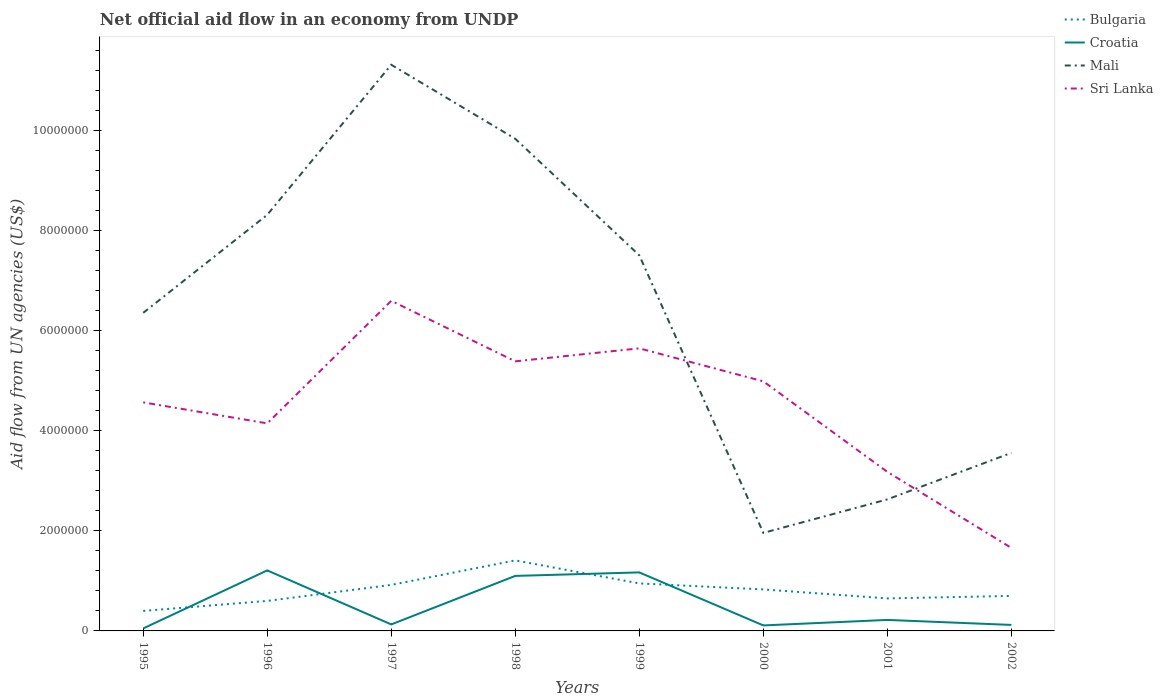How many different coloured lines are there?
Make the answer very short. 4. Across all years, what is the maximum net official aid flow in Sri Lanka?
Keep it short and to the point. 1.66e+06. What is the total net official aid flow in Croatia in the graph?
Your answer should be very brief. -7.00e+04. What is the difference between the highest and the second highest net official aid flow in Croatia?
Provide a succinct answer. 1.16e+06. What is the difference between two consecutive major ticks on the Y-axis?
Your answer should be very brief. 2.00e+06. Are the values on the major ticks of Y-axis written in scientific E-notation?
Your answer should be very brief. No. Does the graph contain grids?
Give a very brief answer. No. Where does the legend appear in the graph?
Give a very brief answer. Top right. How are the legend labels stacked?
Offer a very short reply. Vertical. What is the title of the graph?
Offer a very short reply. Net official aid flow in an economy from UNDP. What is the label or title of the X-axis?
Offer a very short reply. Years. What is the label or title of the Y-axis?
Make the answer very short. Aid flow from UN agencies (US$). What is the Aid flow from UN agencies (US$) in Bulgaria in 1995?
Offer a terse response. 4.00e+05. What is the Aid flow from UN agencies (US$) of Mali in 1995?
Keep it short and to the point. 6.36e+06. What is the Aid flow from UN agencies (US$) of Sri Lanka in 1995?
Provide a succinct answer. 4.57e+06. What is the Aid flow from UN agencies (US$) in Bulgaria in 1996?
Provide a succinct answer. 6.00e+05. What is the Aid flow from UN agencies (US$) in Croatia in 1996?
Keep it short and to the point. 1.21e+06. What is the Aid flow from UN agencies (US$) of Mali in 1996?
Your answer should be very brief. 8.32e+06. What is the Aid flow from UN agencies (US$) in Sri Lanka in 1996?
Give a very brief answer. 4.15e+06. What is the Aid flow from UN agencies (US$) of Bulgaria in 1997?
Give a very brief answer. 9.20e+05. What is the Aid flow from UN agencies (US$) of Mali in 1997?
Provide a short and direct response. 1.13e+07. What is the Aid flow from UN agencies (US$) in Sri Lanka in 1997?
Ensure brevity in your answer.  6.60e+06. What is the Aid flow from UN agencies (US$) in Bulgaria in 1998?
Make the answer very short. 1.41e+06. What is the Aid flow from UN agencies (US$) of Croatia in 1998?
Make the answer very short. 1.10e+06. What is the Aid flow from UN agencies (US$) in Mali in 1998?
Provide a succinct answer. 9.84e+06. What is the Aid flow from UN agencies (US$) in Sri Lanka in 1998?
Make the answer very short. 5.39e+06. What is the Aid flow from UN agencies (US$) in Bulgaria in 1999?
Make the answer very short. 9.50e+05. What is the Aid flow from UN agencies (US$) in Croatia in 1999?
Your response must be concise. 1.17e+06. What is the Aid flow from UN agencies (US$) of Mali in 1999?
Offer a terse response. 7.51e+06. What is the Aid flow from UN agencies (US$) of Sri Lanka in 1999?
Your answer should be very brief. 5.65e+06. What is the Aid flow from UN agencies (US$) of Bulgaria in 2000?
Make the answer very short. 8.30e+05. What is the Aid flow from UN agencies (US$) of Croatia in 2000?
Make the answer very short. 1.10e+05. What is the Aid flow from UN agencies (US$) in Mali in 2000?
Your answer should be very brief. 1.96e+06. What is the Aid flow from UN agencies (US$) in Sri Lanka in 2000?
Give a very brief answer. 4.99e+06. What is the Aid flow from UN agencies (US$) of Bulgaria in 2001?
Ensure brevity in your answer.  6.50e+05. What is the Aid flow from UN agencies (US$) of Mali in 2001?
Your response must be concise. 2.63e+06. What is the Aid flow from UN agencies (US$) of Sri Lanka in 2001?
Your answer should be compact. 3.18e+06. What is the Aid flow from UN agencies (US$) of Bulgaria in 2002?
Your answer should be very brief. 7.00e+05. What is the Aid flow from UN agencies (US$) in Croatia in 2002?
Give a very brief answer. 1.20e+05. What is the Aid flow from UN agencies (US$) in Mali in 2002?
Provide a short and direct response. 3.56e+06. What is the Aid flow from UN agencies (US$) of Sri Lanka in 2002?
Offer a very short reply. 1.66e+06. Across all years, what is the maximum Aid flow from UN agencies (US$) of Bulgaria?
Your response must be concise. 1.41e+06. Across all years, what is the maximum Aid flow from UN agencies (US$) of Croatia?
Your answer should be very brief. 1.21e+06. Across all years, what is the maximum Aid flow from UN agencies (US$) in Mali?
Your response must be concise. 1.13e+07. Across all years, what is the maximum Aid flow from UN agencies (US$) of Sri Lanka?
Offer a terse response. 6.60e+06. Across all years, what is the minimum Aid flow from UN agencies (US$) in Mali?
Give a very brief answer. 1.96e+06. Across all years, what is the minimum Aid flow from UN agencies (US$) in Sri Lanka?
Your answer should be very brief. 1.66e+06. What is the total Aid flow from UN agencies (US$) in Bulgaria in the graph?
Provide a succinct answer. 6.46e+06. What is the total Aid flow from UN agencies (US$) in Croatia in the graph?
Offer a very short reply. 4.11e+06. What is the total Aid flow from UN agencies (US$) in Mali in the graph?
Give a very brief answer. 5.15e+07. What is the total Aid flow from UN agencies (US$) in Sri Lanka in the graph?
Your response must be concise. 3.62e+07. What is the difference between the Aid flow from UN agencies (US$) of Croatia in 1995 and that in 1996?
Your answer should be very brief. -1.16e+06. What is the difference between the Aid flow from UN agencies (US$) of Mali in 1995 and that in 1996?
Give a very brief answer. -1.96e+06. What is the difference between the Aid flow from UN agencies (US$) of Bulgaria in 1995 and that in 1997?
Your answer should be compact. -5.20e+05. What is the difference between the Aid flow from UN agencies (US$) in Mali in 1995 and that in 1997?
Your answer should be very brief. -4.96e+06. What is the difference between the Aid flow from UN agencies (US$) of Sri Lanka in 1995 and that in 1997?
Your answer should be very brief. -2.03e+06. What is the difference between the Aid flow from UN agencies (US$) in Bulgaria in 1995 and that in 1998?
Your answer should be very brief. -1.01e+06. What is the difference between the Aid flow from UN agencies (US$) in Croatia in 1995 and that in 1998?
Offer a terse response. -1.05e+06. What is the difference between the Aid flow from UN agencies (US$) in Mali in 1995 and that in 1998?
Provide a short and direct response. -3.48e+06. What is the difference between the Aid flow from UN agencies (US$) in Sri Lanka in 1995 and that in 1998?
Provide a succinct answer. -8.20e+05. What is the difference between the Aid flow from UN agencies (US$) in Bulgaria in 1995 and that in 1999?
Offer a terse response. -5.50e+05. What is the difference between the Aid flow from UN agencies (US$) in Croatia in 1995 and that in 1999?
Keep it short and to the point. -1.12e+06. What is the difference between the Aid flow from UN agencies (US$) of Mali in 1995 and that in 1999?
Give a very brief answer. -1.15e+06. What is the difference between the Aid flow from UN agencies (US$) in Sri Lanka in 1995 and that in 1999?
Offer a terse response. -1.08e+06. What is the difference between the Aid flow from UN agencies (US$) in Bulgaria in 1995 and that in 2000?
Make the answer very short. -4.30e+05. What is the difference between the Aid flow from UN agencies (US$) of Mali in 1995 and that in 2000?
Provide a short and direct response. 4.40e+06. What is the difference between the Aid flow from UN agencies (US$) of Sri Lanka in 1995 and that in 2000?
Keep it short and to the point. -4.20e+05. What is the difference between the Aid flow from UN agencies (US$) of Bulgaria in 1995 and that in 2001?
Offer a very short reply. -2.50e+05. What is the difference between the Aid flow from UN agencies (US$) of Croatia in 1995 and that in 2001?
Give a very brief answer. -1.70e+05. What is the difference between the Aid flow from UN agencies (US$) in Mali in 1995 and that in 2001?
Your answer should be compact. 3.73e+06. What is the difference between the Aid flow from UN agencies (US$) in Sri Lanka in 1995 and that in 2001?
Make the answer very short. 1.39e+06. What is the difference between the Aid flow from UN agencies (US$) of Bulgaria in 1995 and that in 2002?
Keep it short and to the point. -3.00e+05. What is the difference between the Aid flow from UN agencies (US$) in Mali in 1995 and that in 2002?
Give a very brief answer. 2.80e+06. What is the difference between the Aid flow from UN agencies (US$) of Sri Lanka in 1995 and that in 2002?
Your answer should be compact. 2.91e+06. What is the difference between the Aid flow from UN agencies (US$) in Bulgaria in 1996 and that in 1997?
Your answer should be compact. -3.20e+05. What is the difference between the Aid flow from UN agencies (US$) in Croatia in 1996 and that in 1997?
Your response must be concise. 1.08e+06. What is the difference between the Aid flow from UN agencies (US$) in Mali in 1996 and that in 1997?
Offer a very short reply. -3.00e+06. What is the difference between the Aid flow from UN agencies (US$) in Sri Lanka in 1996 and that in 1997?
Give a very brief answer. -2.45e+06. What is the difference between the Aid flow from UN agencies (US$) of Bulgaria in 1996 and that in 1998?
Make the answer very short. -8.10e+05. What is the difference between the Aid flow from UN agencies (US$) in Mali in 1996 and that in 1998?
Offer a terse response. -1.52e+06. What is the difference between the Aid flow from UN agencies (US$) of Sri Lanka in 1996 and that in 1998?
Your answer should be compact. -1.24e+06. What is the difference between the Aid flow from UN agencies (US$) of Bulgaria in 1996 and that in 1999?
Offer a terse response. -3.50e+05. What is the difference between the Aid flow from UN agencies (US$) in Croatia in 1996 and that in 1999?
Make the answer very short. 4.00e+04. What is the difference between the Aid flow from UN agencies (US$) in Mali in 1996 and that in 1999?
Your answer should be compact. 8.10e+05. What is the difference between the Aid flow from UN agencies (US$) of Sri Lanka in 1996 and that in 1999?
Offer a very short reply. -1.50e+06. What is the difference between the Aid flow from UN agencies (US$) in Bulgaria in 1996 and that in 2000?
Give a very brief answer. -2.30e+05. What is the difference between the Aid flow from UN agencies (US$) in Croatia in 1996 and that in 2000?
Provide a succinct answer. 1.10e+06. What is the difference between the Aid flow from UN agencies (US$) of Mali in 1996 and that in 2000?
Offer a very short reply. 6.36e+06. What is the difference between the Aid flow from UN agencies (US$) in Sri Lanka in 1996 and that in 2000?
Ensure brevity in your answer.  -8.40e+05. What is the difference between the Aid flow from UN agencies (US$) of Bulgaria in 1996 and that in 2001?
Your answer should be compact. -5.00e+04. What is the difference between the Aid flow from UN agencies (US$) in Croatia in 1996 and that in 2001?
Provide a succinct answer. 9.90e+05. What is the difference between the Aid flow from UN agencies (US$) of Mali in 1996 and that in 2001?
Make the answer very short. 5.69e+06. What is the difference between the Aid flow from UN agencies (US$) of Sri Lanka in 1996 and that in 2001?
Keep it short and to the point. 9.70e+05. What is the difference between the Aid flow from UN agencies (US$) of Bulgaria in 1996 and that in 2002?
Ensure brevity in your answer.  -1.00e+05. What is the difference between the Aid flow from UN agencies (US$) in Croatia in 1996 and that in 2002?
Your answer should be very brief. 1.09e+06. What is the difference between the Aid flow from UN agencies (US$) in Mali in 1996 and that in 2002?
Give a very brief answer. 4.76e+06. What is the difference between the Aid flow from UN agencies (US$) of Sri Lanka in 1996 and that in 2002?
Your answer should be compact. 2.49e+06. What is the difference between the Aid flow from UN agencies (US$) in Bulgaria in 1997 and that in 1998?
Your response must be concise. -4.90e+05. What is the difference between the Aid flow from UN agencies (US$) of Croatia in 1997 and that in 1998?
Make the answer very short. -9.70e+05. What is the difference between the Aid flow from UN agencies (US$) of Mali in 1997 and that in 1998?
Your answer should be very brief. 1.48e+06. What is the difference between the Aid flow from UN agencies (US$) in Sri Lanka in 1997 and that in 1998?
Your answer should be very brief. 1.21e+06. What is the difference between the Aid flow from UN agencies (US$) of Croatia in 1997 and that in 1999?
Provide a succinct answer. -1.04e+06. What is the difference between the Aid flow from UN agencies (US$) in Mali in 1997 and that in 1999?
Provide a short and direct response. 3.81e+06. What is the difference between the Aid flow from UN agencies (US$) in Sri Lanka in 1997 and that in 1999?
Provide a succinct answer. 9.50e+05. What is the difference between the Aid flow from UN agencies (US$) in Bulgaria in 1997 and that in 2000?
Your answer should be very brief. 9.00e+04. What is the difference between the Aid flow from UN agencies (US$) of Mali in 1997 and that in 2000?
Keep it short and to the point. 9.36e+06. What is the difference between the Aid flow from UN agencies (US$) in Sri Lanka in 1997 and that in 2000?
Provide a succinct answer. 1.61e+06. What is the difference between the Aid flow from UN agencies (US$) of Mali in 1997 and that in 2001?
Ensure brevity in your answer.  8.69e+06. What is the difference between the Aid flow from UN agencies (US$) in Sri Lanka in 1997 and that in 2001?
Your response must be concise. 3.42e+06. What is the difference between the Aid flow from UN agencies (US$) in Croatia in 1997 and that in 2002?
Give a very brief answer. 10000. What is the difference between the Aid flow from UN agencies (US$) of Mali in 1997 and that in 2002?
Provide a short and direct response. 7.76e+06. What is the difference between the Aid flow from UN agencies (US$) in Sri Lanka in 1997 and that in 2002?
Your answer should be compact. 4.94e+06. What is the difference between the Aid flow from UN agencies (US$) of Bulgaria in 1998 and that in 1999?
Keep it short and to the point. 4.60e+05. What is the difference between the Aid flow from UN agencies (US$) in Croatia in 1998 and that in 1999?
Make the answer very short. -7.00e+04. What is the difference between the Aid flow from UN agencies (US$) in Mali in 1998 and that in 1999?
Provide a short and direct response. 2.33e+06. What is the difference between the Aid flow from UN agencies (US$) in Bulgaria in 1998 and that in 2000?
Offer a terse response. 5.80e+05. What is the difference between the Aid flow from UN agencies (US$) of Croatia in 1998 and that in 2000?
Ensure brevity in your answer.  9.90e+05. What is the difference between the Aid flow from UN agencies (US$) of Mali in 1998 and that in 2000?
Your answer should be compact. 7.88e+06. What is the difference between the Aid flow from UN agencies (US$) in Bulgaria in 1998 and that in 2001?
Your answer should be compact. 7.60e+05. What is the difference between the Aid flow from UN agencies (US$) in Croatia in 1998 and that in 2001?
Make the answer very short. 8.80e+05. What is the difference between the Aid flow from UN agencies (US$) of Mali in 1998 and that in 2001?
Offer a terse response. 7.21e+06. What is the difference between the Aid flow from UN agencies (US$) in Sri Lanka in 1998 and that in 2001?
Offer a terse response. 2.21e+06. What is the difference between the Aid flow from UN agencies (US$) of Bulgaria in 1998 and that in 2002?
Provide a short and direct response. 7.10e+05. What is the difference between the Aid flow from UN agencies (US$) in Croatia in 1998 and that in 2002?
Your response must be concise. 9.80e+05. What is the difference between the Aid flow from UN agencies (US$) in Mali in 1998 and that in 2002?
Offer a terse response. 6.28e+06. What is the difference between the Aid flow from UN agencies (US$) of Sri Lanka in 1998 and that in 2002?
Your response must be concise. 3.73e+06. What is the difference between the Aid flow from UN agencies (US$) of Croatia in 1999 and that in 2000?
Offer a very short reply. 1.06e+06. What is the difference between the Aid flow from UN agencies (US$) of Mali in 1999 and that in 2000?
Your answer should be very brief. 5.55e+06. What is the difference between the Aid flow from UN agencies (US$) of Sri Lanka in 1999 and that in 2000?
Your answer should be compact. 6.60e+05. What is the difference between the Aid flow from UN agencies (US$) of Bulgaria in 1999 and that in 2001?
Give a very brief answer. 3.00e+05. What is the difference between the Aid flow from UN agencies (US$) in Croatia in 1999 and that in 2001?
Offer a very short reply. 9.50e+05. What is the difference between the Aid flow from UN agencies (US$) of Mali in 1999 and that in 2001?
Your answer should be very brief. 4.88e+06. What is the difference between the Aid flow from UN agencies (US$) in Sri Lanka in 1999 and that in 2001?
Offer a very short reply. 2.47e+06. What is the difference between the Aid flow from UN agencies (US$) of Croatia in 1999 and that in 2002?
Your answer should be compact. 1.05e+06. What is the difference between the Aid flow from UN agencies (US$) of Mali in 1999 and that in 2002?
Ensure brevity in your answer.  3.95e+06. What is the difference between the Aid flow from UN agencies (US$) of Sri Lanka in 1999 and that in 2002?
Offer a very short reply. 3.99e+06. What is the difference between the Aid flow from UN agencies (US$) in Bulgaria in 2000 and that in 2001?
Offer a terse response. 1.80e+05. What is the difference between the Aid flow from UN agencies (US$) in Croatia in 2000 and that in 2001?
Provide a short and direct response. -1.10e+05. What is the difference between the Aid flow from UN agencies (US$) in Mali in 2000 and that in 2001?
Provide a succinct answer. -6.70e+05. What is the difference between the Aid flow from UN agencies (US$) in Sri Lanka in 2000 and that in 2001?
Ensure brevity in your answer.  1.81e+06. What is the difference between the Aid flow from UN agencies (US$) in Bulgaria in 2000 and that in 2002?
Make the answer very short. 1.30e+05. What is the difference between the Aid flow from UN agencies (US$) in Mali in 2000 and that in 2002?
Give a very brief answer. -1.60e+06. What is the difference between the Aid flow from UN agencies (US$) in Sri Lanka in 2000 and that in 2002?
Ensure brevity in your answer.  3.33e+06. What is the difference between the Aid flow from UN agencies (US$) in Mali in 2001 and that in 2002?
Offer a very short reply. -9.30e+05. What is the difference between the Aid flow from UN agencies (US$) in Sri Lanka in 2001 and that in 2002?
Your answer should be very brief. 1.52e+06. What is the difference between the Aid flow from UN agencies (US$) of Bulgaria in 1995 and the Aid flow from UN agencies (US$) of Croatia in 1996?
Offer a very short reply. -8.10e+05. What is the difference between the Aid flow from UN agencies (US$) of Bulgaria in 1995 and the Aid flow from UN agencies (US$) of Mali in 1996?
Provide a succinct answer. -7.92e+06. What is the difference between the Aid flow from UN agencies (US$) in Bulgaria in 1995 and the Aid flow from UN agencies (US$) in Sri Lanka in 1996?
Make the answer very short. -3.75e+06. What is the difference between the Aid flow from UN agencies (US$) in Croatia in 1995 and the Aid flow from UN agencies (US$) in Mali in 1996?
Offer a very short reply. -8.27e+06. What is the difference between the Aid flow from UN agencies (US$) of Croatia in 1995 and the Aid flow from UN agencies (US$) of Sri Lanka in 1996?
Offer a very short reply. -4.10e+06. What is the difference between the Aid flow from UN agencies (US$) in Mali in 1995 and the Aid flow from UN agencies (US$) in Sri Lanka in 1996?
Offer a very short reply. 2.21e+06. What is the difference between the Aid flow from UN agencies (US$) of Bulgaria in 1995 and the Aid flow from UN agencies (US$) of Mali in 1997?
Keep it short and to the point. -1.09e+07. What is the difference between the Aid flow from UN agencies (US$) in Bulgaria in 1995 and the Aid flow from UN agencies (US$) in Sri Lanka in 1997?
Your answer should be very brief. -6.20e+06. What is the difference between the Aid flow from UN agencies (US$) of Croatia in 1995 and the Aid flow from UN agencies (US$) of Mali in 1997?
Your response must be concise. -1.13e+07. What is the difference between the Aid flow from UN agencies (US$) of Croatia in 1995 and the Aid flow from UN agencies (US$) of Sri Lanka in 1997?
Provide a succinct answer. -6.55e+06. What is the difference between the Aid flow from UN agencies (US$) of Bulgaria in 1995 and the Aid flow from UN agencies (US$) of Croatia in 1998?
Give a very brief answer. -7.00e+05. What is the difference between the Aid flow from UN agencies (US$) in Bulgaria in 1995 and the Aid flow from UN agencies (US$) in Mali in 1998?
Offer a terse response. -9.44e+06. What is the difference between the Aid flow from UN agencies (US$) in Bulgaria in 1995 and the Aid flow from UN agencies (US$) in Sri Lanka in 1998?
Make the answer very short. -4.99e+06. What is the difference between the Aid flow from UN agencies (US$) in Croatia in 1995 and the Aid flow from UN agencies (US$) in Mali in 1998?
Provide a short and direct response. -9.79e+06. What is the difference between the Aid flow from UN agencies (US$) in Croatia in 1995 and the Aid flow from UN agencies (US$) in Sri Lanka in 1998?
Ensure brevity in your answer.  -5.34e+06. What is the difference between the Aid flow from UN agencies (US$) in Mali in 1995 and the Aid flow from UN agencies (US$) in Sri Lanka in 1998?
Your answer should be compact. 9.70e+05. What is the difference between the Aid flow from UN agencies (US$) of Bulgaria in 1995 and the Aid flow from UN agencies (US$) of Croatia in 1999?
Your response must be concise. -7.70e+05. What is the difference between the Aid flow from UN agencies (US$) of Bulgaria in 1995 and the Aid flow from UN agencies (US$) of Mali in 1999?
Ensure brevity in your answer.  -7.11e+06. What is the difference between the Aid flow from UN agencies (US$) of Bulgaria in 1995 and the Aid flow from UN agencies (US$) of Sri Lanka in 1999?
Your response must be concise. -5.25e+06. What is the difference between the Aid flow from UN agencies (US$) in Croatia in 1995 and the Aid flow from UN agencies (US$) in Mali in 1999?
Your response must be concise. -7.46e+06. What is the difference between the Aid flow from UN agencies (US$) in Croatia in 1995 and the Aid flow from UN agencies (US$) in Sri Lanka in 1999?
Provide a short and direct response. -5.60e+06. What is the difference between the Aid flow from UN agencies (US$) in Mali in 1995 and the Aid flow from UN agencies (US$) in Sri Lanka in 1999?
Give a very brief answer. 7.10e+05. What is the difference between the Aid flow from UN agencies (US$) of Bulgaria in 1995 and the Aid flow from UN agencies (US$) of Mali in 2000?
Your answer should be compact. -1.56e+06. What is the difference between the Aid flow from UN agencies (US$) in Bulgaria in 1995 and the Aid flow from UN agencies (US$) in Sri Lanka in 2000?
Your answer should be compact. -4.59e+06. What is the difference between the Aid flow from UN agencies (US$) of Croatia in 1995 and the Aid flow from UN agencies (US$) of Mali in 2000?
Offer a very short reply. -1.91e+06. What is the difference between the Aid flow from UN agencies (US$) in Croatia in 1995 and the Aid flow from UN agencies (US$) in Sri Lanka in 2000?
Ensure brevity in your answer.  -4.94e+06. What is the difference between the Aid flow from UN agencies (US$) of Mali in 1995 and the Aid flow from UN agencies (US$) of Sri Lanka in 2000?
Your answer should be compact. 1.37e+06. What is the difference between the Aid flow from UN agencies (US$) in Bulgaria in 1995 and the Aid flow from UN agencies (US$) in Croatia in 2001?
Make the answer very short. 1.80e+05. What is the difference between the Aid flow from UN agencies (US$) in Bulgaria in 1995 and the Aid flow from UN agencies (US$) in Mali in 2001?
Give a very brief answer. -2.23e+06. What is the difference between the Aid flow from UN agencies (US$) of Bulgaria in 1995 and the Aid flow from UN agencies (US$) of Sri Lanka in 2001?
Keep it short and to the point. -2.78e+06. What is the difference between the Aid flow from UN agencies (US$) of Croatia in 1995 and the Aid flow from UN agencies (US$) of Mali in 2001?
Your response must be concise. -2.58e+06. What is the difference between the Aid flow from UN agencies (US$) in Croatia in 1995 and the Aid flow from UN agencies (US$) in Sri Lanka in 2001?
Your answer should be compact. -3.13e+06. What is the difference between the Aid flow from UN agencies (US$) of Mali in 1995 and the Aid flow from UN agencies (US$) of Sri Lanka in 2001?
Provide a short and direct response. 3.18e+06. What is the difference between the Aid flow from UN agencies (US$) in Bulgaria in 1995 and the Aid flow from UN agencies (US$) in Croatia in 2002?
Your response must be concise. 2.80e+05. What is the difference between the Aid flow from UN agencies (US$) in Bulgaria in 1995 and the Aid flow from UN agencies (US$) in Mali in 2002?
Your answer should be very brief. -3.16e+06. What is the difference between the Aid flow from UN agencies (US$) in Bulgaria in 1995 and the Aid flow from UN agencies (US$) in Sri Lanka in 2002?
Keep it short and to the point. -1.26e+06. What is the difference between the Aid flow from UN agencies (US$) of Croatia in 1995 and the Aid flow from UN agencies (US$) of Mali in 2002?
Provide a succinct answer. -3.51e+06. What is the difference between the Aid flow from UN agencies (US$) in Croatia in 1995 and the Aid flow from UN agencies (US$) in Sri Lanka in 2002?
Your answer should be very brief. -1.61e+06. What is the difference between the Aid flow from UN agencies (US$) in Mali in 1995 and the Aid flow from UN agencies (US$) in Sri Lanka in 2002?
Make the answer very short. 4.70e+06. What is the difference between the Aid flow from UN agencies (US$) in Bulgaria in 1996 and the Aid flow from UN agencies (US$) in Croatia in 1997?
Ensure brevity in your answer.  4.70e+05. What is the difference between the Aid flow from UN agencies (US$) of Bulgaria in 1996 and the Aid flow from UN agencies (US$) of Mali in 1997?
Ensure brevity in your answer.  -1.07e+07. What is the difference between the Aid flow from UN agencies (US$) of Bulgaria in 1996 and the Aid flow from UN agencies (US$) of Sri Lanka in 1997?
Your answer should be very brief. -6.00e+06. What is the difference between the Aid flow from UN agencies (US$) of Croatia in 1996 and the Aid flow from UN agencies (US$) of Mali in 1997?
Keep it short and to the point. -1.01e+07. What is the difference between the Aid flow from UN agencies (US$) in Croatia in 1996 and the Aid flow from UN agencies (US$) in Sri Lanka in 1997?
Offer a terse response. -5.39e+06. What is the difference between the Aid flow from UN agencies (US$) in Mali in 1996 and the Aid flow from UN agencies (US$) in Sri Lanka in 1997?
Your answer should be very brief. 1.72e+06. What is the difference between the Aid flow from UN agencies (US$) in Bulgaria in 1996 and the Aid flow from UN agencies (US$) in Croatia in 1998?
Make the answer very short. -5.00e+05. What is the difference between the Aid flow from UN agencies (US$) of Bulgaria in 1996 and the Aid flow from UN agencies (US$) of Mali in 1998?
Keep it short and to the point. -9.24e+06. What is the difference between the Aid flow from UN agencies (US$) in Bulgaria in 1996 and the Aid flow from UN agencies (US$) in Sri Lanka in 1998?
Offer a very short reply. -4.79e+06. What is the difference between the Aid flow from UN agencies (US$) of Croatia in 1996 and the Aid flow from UN agencies (US$) of Mali in 1998?
Keep it short and to the point. -8.63e+06. What is the difference between the Aid flow from UN agencies (US$) in Croatia in 1996 and the Aid flow from UN agencies (US$) in Sri Lanka in 1998?
Offer a terse response. -4.18e+06. What is the difference between the Aid flow from UN agencies (US$) of Mali in 1996 and the Aid flow from UN agencies (US$) of Sri Lanka in 1998?
Offer a very short reply. 2.93e+06. What is the difference between the Aid flow from UN agencies (US$) of Bulgaria in 1996 and the Aid flow from UN agencies (US$) of Croatia in 1999?
Provide a succinct answer. -5.70e+05. What is the difference between the Aid flow from UN agencies (US$) of Bulgaria in 1996 and the Aid flow from UN agencies (US$) of Mali in 1999?
Make the answer very short. -6.91e+06. What is the difference between the Aid flow from UN agencies (US$) of Bulgaria in 1996 and the Aid flow from UN agencies (US$) of Sri Lanka in 1999?
Provide a succinct answer. -5.05e+06. What is the difference between the Aid flow from UN agencies (US$) in Croatia in 1996 and the Aid flow from UN agencies (US$) in Mali in 1999?
Give a very brief answer. -6.30e+06. What is the difference between the Aid flow from UN agencies (US$) of Croatia in 1996 and the Aid flow from UN agencies (US$) of Sri Lanka in 1999?
Provide a short and direct response. -4.44e+06. What is the difference between the Aid flow from UN agencies (US$) of Mali in 1996 and the Aid flow from UN agencies (US$) of Sri Lanka in 1999?
Offer a terse response. 2.67e+06. What is the difference between the Aid flow from UN agencies (US$) in Bulgaria in 1996 and the Aid flow from UN agencies (US$) in Croatia in 2000?
Make the answer very short. 4.90e+05. What is the difference between the Aid flow from UN agencies (US$) in Bulgaria in 1996 and the Aid flow from UN agencies (US$) in Mali in 2000?
Give a very brief answer. -1.36e+06. What is the difference between the Aid flow from UN agencies (US$) of Bulgaria in 1996 and the Aid flow from UN agencies (US$) of Sri Lanka in 2000?
Your answer should be compact. -4.39e+06. What is the difference between the Aid flow from UN agencies (US$) in Croatia in 1996 and the Aid flow from UN agencies (US$) in Mali in 2000?
Make the answer very short. -7.50e+05. What is the difference between the Aid flow from UN agencies (US$) of Croatia in 1996 and the Aid flow from UN agencies (US$) of Sri Lanka in 2000?
Ensure brevity in your answer.  -3.78e+06. What is the difference between the Aid flow from UN agencies (US$) in Mali in 1996 and the Aid flow from UN agencies (US$) in Sri Lanka in 2000?
Offer a terse response. 3.33e+06. What is the difference between the Aid flow from UN agencies (US$) of Bulgaria in 1996 and the Aid flow from UN agencies (US$) of Mali in 2001?
Provide a succinct answer. -2.03e+06. What is the difference between the Aid flow from UN agencies (US$) in Bulgaria in 1996 and the Aid flow from UN agencies (US$) in Sri Lanka in 2001?
Give a very brief answer. -2.58e+06. What is the difference between the Aid flow from UN agencies (US$) of Croatia in 1996 and the Aid flow from UN agencies (US$) of Mali in 2001?
Offer a terse response. -1.42e+06. What is the difference between the Aid flow from UN agencies (US$) in Croatia in 1996 and the Aid flow from UN agencies (US$) in Sri Lanka in 2001?
Make the answer very short. -1.97e+06. What is the difference between the Aid flow from UN agencies (US$) in Mali in 1996 and the Aid flow from UN agencies (US$) in Sri Lanka in 2001?
Keep it short and to the point. 5.14e+06. What is the difference between the Aid flow from UN agencies (US$) in Bulgaria in 1996 and the Aid flow from UN agencies (US$) in Mali in 2002?
Your answer should be very brief. -2.96e+06. What is the difference between the Aid flow from UN agencies (US$) of Bulgaria in 1996 and the Aid flow from UN agencies (US$) of Sri Lanka in 2002?
Keep it short and to the point. -1.06e+06. What is the difference between the Aid flow from UN agencies (US$) of Croatia in 1996 and the Aid flow from UN agencies (US$) of Mali in 2002?
Offer a very short reply. -2.35e+06. What is the difference between the Aid flow from UN agencies (US$) of Croatia in 1996 and the Aid flow from UN agencies (US$) of Sri Lanka in 2002?
Give a very brief answer. -4.50e+05. What is the difference between the Aid flow from UN agencies (US$) of Mali in 1996 and the Aid flow from UN agencies (US$) of Sri Lanka in 2002?
Your answer should be very brief. 6.66e+06. What is the difference between the Aid flow from UN agencies (US$) in Bulgaria in 1997 and the Aid flow from UN agencies (US$) in Croatia in 1998?
Your response must be concise. -1.80e+05. What is the difference between the Aid flow from UN agencies (US$) of Bulgaria in 1997 and the Aid flow from UN agencies (US$) of Mali in 1998?
Your answer should be very brief. -8.92e+06. What is the difference between the Aid flow from UN agencies (US$) of Bulgaria in 1997 and the Aid flow from UN agencies (US$) of Sri Lanka in 1998?
Your response must be concise. -4.47e+06. What is the difference between the Aid flow from UN agencies (US$) of Croatia in 1997 and the Aid flow from UN agencies (US$) of Mali in 1998?
Ensure brevity in your answer.  -9.71e+06. What is the difference between the Aid flow from UN agencies (US$) of Croatia in 1997 and the Aid flow from UN agencies (US$) of Sri Lanka in 1998?
Provide a succinct answer. -5.26e+06. What is the difference between the Aid flow from UN agencies (US$) of Mali in 1997 and the Aid flow from UN agencies (US$) of Sri Lanka in 1998?
Your response must be concise. 5.93e+06. What is the difference between the Aid flow from UN agencies (US$) of Bulgaria in 1997 and the Aid flow from UN agencies (US$) of Mali in 1999?
Your answer should be compact. -6.59e+06. What is the difference between the Aid flow from UN agencies (US$) in Bulgaria in 1997 and the Aid flow from UN agencies (US$) in Sri Lanka in 1999?
Give a very brief answer. -4.73e+06. What is the difference between the Aid flow from UN agencies (US$) of Croatia in 1997 and the Aid flow from UN agencies (US$) of Mali in 1999?
Make the answer very short. -7.38e+06. What is the difference between the Aid flow from UN agencies (US$) in Croatia in 1997 and the Aid flow from UN agencies (US$) in Sri Lanka in 1999?
Offer a terse response. -5.52e+06. What is the difference between the Aid flow from UN agencies (US$) in Mali in 1997 and the Aid flow from UN agencies (US$) in Sri Lanka in 1999?
Keep it short and to the point. 5.67e+06. What is the difference between the Aid flow from UN agencies (US$) of Bulgaria in 1997 and the Aid flow from UN agencies (US$) of Croatia in 2000?
Your answer should be compact. 8.10e+05. What is the difference between the Aid flow from UN agencies (US$) of Bulgaria in 1997 and the Aid flow from UN agencies (US$) of Mali in 2000?
Make the answer very short. -1.04e+06. What is the difference between the Aid flow from UN agencies (US$) of Bulgaria in 1997 and the Aid flow from UN agencies (US$) of Sri Lanka in 2000?
Offer a very short reply. -4.07e+06. What is the difference between the Aid flow from UN agencies (US$) in Croatia in 1997 and the Aid flow from UN agencies (US$) in Mali in 2000?
Give a very brief answer. -1.83e+06. What is the difference between the Aid flow from UN agencies (US$) in Croatia in 1997 and the Aid flow from UN agencies (US$) in Sri Lanka in 2000?
Your response must be concise. -4.86e+06. What is the difference between the Aid flow from UN agencies (US$) of Mali in 1997 and the Aid flow from UN agencies (US$) of Sri Lanka in 2000?
Ensure brevity in your answer.  6.33e+06. What is the difference between the Aid flow from UN agencies (US$) of Bulgaria in 1997 and the Aid flow from UN agencies (US$) of Mali in 2001?
Your response must be concise. -1.71e+06. What is the difference between the Aid flow from UN agencies (US$) in Bulgaria in 1997 and the Aid flow from UN agencies (US$) in Sri Lanka in 2001?
Offer a terse response. -2.26e+06. What is the difference between the Aid flow from UN agencies (US$) in Croatia in 1997 and the Aid flow from UN agencies (US$) in Mali in 2001?
Keep it short and to the point. -2.50e+06. What is the difference between the Aid flow from UN agencies (US$) of Croatia in 1997 and the Aid flow from UN agencies (US$) of Sri Lanka in 2001?
Offer a terse response. -3.05e+06. What is the difference between the Aid flow from UN agencies (US$) in Mali in 1997 and the Aid flow from UN agencies (US$) in Sri Lanka in 2001?
Your answer should be very brief. 8.14e+06. What is the difference between the Aid flow from UN agencies (US$) in Bulgaria in 1997 and the Aid flow from UN agencies (US$) in Mali in 2002?
Your response must be concise. -2.64e+06. What is the difference between the Aid flow from UN agencies (US$) in Bulgaria in 1997 and the Aid flow from UN agencies (US$) in Sri Lanka in 2002?
Provide a short and direct response. -7.40e+05. What is the difference between the Aid flow from UN agencies (US$) in Croatia in 1997 and the Aid flow from UN agencies (US$) in Mali in 2002?
Your response must be concise. -3.43e+06. What is the difference between the Aid flow from UN agencies (US$) of Croatia in 1997 and the Aid flow from UN agencies (US$) of Sri Lanka in 2002?
Offer a very short reply. -1.53e+06. What is the difference between the Aid flow from UN agencies (US$) of Mali in 1997 and the Aid flow from UN agencies (US$) of Sri Lanka in 2002?
Your answer should be very brief. 9.66e+06. What is the difference between the Aid flow from UN agencies (US$) of Bulgaria in 1998 and the Aid flow from UN agencies (US$) of Mali in 1999?
Give a very brief answer. -6.10e+06. What is the difference between the Aid flow from UN agencies (US$) of Bulgaria in 1998 and the Aid flow from UN agencies (US$) of Sri Lanka in 1999?
Give a very brief answer. -4.24e+06. What is the difference between the Aid flow from UN agencies (US$) of Croatia in 1998 and the Aid flow from UN agencies (US$) of Mali in 1999?
Give a very brief answer. -6.41e+06. What is the difference between the Aid flow from UN agencies (US$) of Croatia in 1998 and the Aid flow from UN agencies (US$) of Sri Lanka in 1999?
Make the answer very short. -4.55e+06. What is the difference between the Aid flow from UN agencies (US$) in Mali in 1998 and the Aid flow from UN agencies (US$) in Sri Lanka in 1999?
Offer a very short reply. 4.19e+06. What is the difference between the Aid flow from UN agencies (US$) in Bulgaria in 1998 and the Aid flow from UN agencies (US$) in Croatia in 2000?
Make the answer very short. 1.30e+06. What is the difference between the Aid flow from UN agencies (US$) in Bulgaria in 1998 and the Aid flow from UN agencies (US$) in Mali in 2000?
Give a very brief answer. -5.50e+05. What is the difference between the Aid flow from UN agencies (US$) in Bulgaria in 1998 and the Aid flow from UN agencies (US$) in Sri Lanka in 2000?
Keep it short and to the point. -3.58e+06. What is the difference between the Aid flow from UN agencies (US$) in Croatia in 1998 and the Aid flow from UN agencies (US$) in Mali in 2000?
Your response must be concise. -8.60e+05. What is the difference between the Aid flow from UN agencies (US$) in Croatia in 1998 and the Aid flow from UN agencies (US$) in Sri Lanka in 2000?
Give a very brief answer. -3.89e+06. What is the difference between the Aid flow from UN agencies (US$) of Mali in 1998 and the Aid flow from UN agencies (US$) of Sri Lanka in 2000?
Provide a short and direct response. 4.85e+06. What is the difference between the Aid flow from UN agencies (US$) in Bulgaria in 1998 and the Aid flow from UN agencies (US$) in Croatia in 2001?
Offer a terse response. 1.19e+06. What is the difference between the Aid flow from UN agencies (US$) in Bulgaria in 1998 and the Aid flow from UN agencies (US$) in Mali in 2001?
Make the answer very short. -1.22e+06. What is the difference between the Aid flow from UN agencies (US$) of Bulgaria in 1998 and the Aid flow from UN agencies (US$) of Sri Lanka in 2001?
Your answer should be very brief. -1.77e+06. What is the difference between the Aid flow from UN agencies (US$) in Croatia in 1998 and the Aid flow from UN agencies (US$) in Mali in 2001?
Your answer should be compact. -1.53e+06. What is the difference between the Aid flow from UN agencies (US$) in Croatia in 1998 and the Aid flow from UN agencies (US$) in Sri Lanka in 2001?
Offer a very short reply. -2.08e+06. What is the difference between the Aid flow from UN agencies (US$) of Mali in 1998 and the Aid flow from UN agencies (US$) of Sri Lanka in 2001?
Keep it short and to the point. 6.66e+06. What is the difference between the Aid flow from UN agencies (US$) in Bulgaria in 1998 and the Aid flow from UN agencies (US$) in Croatia in 2002?
Offer a terse response. 1.29e+06. What is the difference between the Aid flow from UN agencies (US$) in Bulgaria in 1998 and the Aid flow from UN agencies (US$) in Mali in 2002?
Ensure brevity in your answer.  -2.15e+06. What is the difference between the Aid flow from UN agencies (US$) in Bulgaria in 1998 and the Aid flow from UN agencies (US$) in Sri Lanka in 2002?
Provide a short and direct response. -2.50e+05. What is the difference between the Aid flow from UN agencies (US$) of Croatia in 1998 and the Aid flow from UN agencies (US$) of Mali in 2002?
Offer a very short reply. -2.46e+06. What is the difference between the Aid flow from UN agencies (US$) in Croatia in 1998 and the Aid flow from UN agencies (US$) in Sri Lanka in 2002?
Ensure brevity in your answer.  -5.60e+05. What is the difference between the Aid flow from UN agencies (US$) of Mali in 1998 and the Aid flow from UN agencies (US$) of Sri Lanka in 2002?
Provide a short and direct response. 8.18e+06. What is the difference between the Aid flow from UN agencies (US$) in Bulgaria in 1999 and the Aid flow from UN agencies (US$) in Croatia in 2000?
Provide a succinct answer. 8.40e+05. What is the difference between the Aid flow from UN agencies (US$) of Bulgaria in 1999 and the Aid flow from UN agencies (US$) of Mali in 2000?
Provide a succinct answer. -1.01e+06. What is the difference between the Aid flow from UN agencies (US$) of Bulgaria in 1999 and the Aid flow from UN agencies (US$) of Sri Lanka in 2000?
Keep it short and to the point. -4.04e+06. What is the difference between the Aid flow from UN agencies (US$) of Croatia in 1999 and the Aid flow from UN agencies (US$) of Mali in 2000?
Ensure brevity in your answer.  -7.90e+05. What is the difference between the Aid flow from UN agencies (US$) of Croatia in 1999 and the Aid flow from UN agencies (US$) of Sri Lanka in 2000?
Keep it short and to the point. -3.82e+06. What is the difference between the Aid flow from UN agencies (US$) of Mali in 1999 and the Aid flow from UN agencies (US$) of Sri Lanka in 2000?
Provide a short and direct response. 2.52e+06. What is the difference between the Aid flow from UN agencies (US$) of Bulgaria in 1999 and the Aid flow from UN agencies (US$) of Croatia in 2001?
Your answer should be very brief. 7.30e+05. What is the difference between the Aid flow from UN agencies (US$) in Bulgaria in 1999 and the Aid flow from UN agencies (US$) in Mali in 2001?
Make the answer very short. -1.68e+06. What is the difference between the Aid flow from UN agencies (US$) in Bulgaria in 1999 and the Aid flow from UN agencies (US$) in Sri Lanka in 2001?
Give a very brief answer. -2.23e+06. What is the difference between the Aid flow from UN agencies (US$) in Croatia in 1999 and the Aid flow from UN agencies (US$) in Mali in 2001?
Ensure brevity in your answer.  -1.46e+06. What is the difference between the Aid flow from UN agencies (US$) of Croatia in 1999 and the Aid flow from UN agencies (US$) of Sri Lanka in 2001?
Your answer should be compact. -2.01e+06. What is the difference between the Aid flow from UN agencies (US$) in Mali in 1999 and the Aid flow from UN agencies (US$) in Sri Lanka in 2001?
Give a very brief answer. 4.33e+06. What is the difference between the Aid flow from UN agencies (US$) in Bulgaria in 1999 and the Aid flow from UN agencies (US$) in Croatia in 2002?
Ensure brevity in your answer.  8.30e+05. What is the difference between the Aid flow from UN agencies (US$) of Bulgaria in 1999 and the Aid flow from UN agencies (US$) of Mali in 2002?
Your answer should be very brief. -2.61e+06. What is the difference between the Aid flow from UN agencies (US$) in Bulgaria in 1999 and the Aid flow from UN agencies (US$) in Sri Lanka in 2002?
Your answer should be very brief. -7.10e+05. What is the difference between the Aid flow from UN agencies (US$) of Croatia in 1999 and the Aid flow from UN agencies (US$) of Mali in 2002?
Provide a succinct answer. -2.39e+06. What is the difference between the Aid flow from UN agencies (US$) in Croatia in 1999 and the Aid flow from UN agencies (US$) in Sri Lanka in 2002?
Give a very brief answer. -4.90e+05. What is the difference between the Aid flow from UN agencies (US$) in Mali in 1999 and the Aid flow from UN agencies (US$) in Sri Lanka in 2002?
Give a very brief answer. 5.85e+06. What is the difference between the Aid flow from UN agencies (US$) in Bulgaria in 2000 and the Aid flow from UN agencies (US$) in Croatia in 2001?
Your answer should be compact. 6.10e+05. What is the difference between the Aid flow from UN agencies (US$) in Bulgaria in 2000 and the Aid flow from UN agencies (US$) in Mali in 2001?
Your answer should be compact. -1.80e+06. What is the difference between the Aid flow from UN agencies (US$) of Bulgaria in 2000 and the Aid flow from UN agencies (US$) of Sri Lanka in 2001?
Ensure brevity in your answer.  -2.35e+06. What is the difference between the Aid flow from UN agencies (US$) of Croatia in 2000 and the Aid flow from UN agencies (US$) of Mali in 2001?
Offer a terse response. -2.52e+06. What is the difference between the Aid flow from UN agencies (US$) in Croatia in 2000 and the Aid flow from UN agencies (US$) in Sri Lanka in 2001?
Your response must be concise. -3.07e+06. What is the difference between the Aid flow from UN agencies (US$) in Mali in 2000 and the Aid flow from UN agencies (US$) in Sri Lanka in 2001?
Offer a very short reply. -1.22e+06. What is the difference between the Aid flow from UN agencies (US$) of Bulgaria in 2000 and the Aid flow from UN agencies (US$) of Croatia in 2002?
Offer a very short reply. 7.10e+05. What is the difference between the Aid flow from UN agencies (US$) in Bulgaria in 2000 and the Aid flow from UN agencies (US$) in Mali in 2002?
Make the answer very short. -2.73e+06. What is the difference between the Aid flow from UN agencies (US$) in Bulgaria in 2000 and the Aid flow from UN agencies (US$) in Sri Lanka in 2002?
Offer a terse response. -8.30e+05. What is the difference between the Aid flow from UN agencies (US$) of Croatia in 2000 and the Aid flow from UN agencies (US$) of Mali in 2002?
Offer a very short reply. -3.45e+06. What is the difference between the Aid flow from UN agencies (US$) of Croatia in 2000 and the Aid flow from UN agencies (US$) of Sri Lanka in 2002?
Your answer should be compact. -1.55e+06. What is the difference between the Aid flow from UN agencies (US$) of Mali in 2000 and the Aid flow from UN agencies (US$) of Sri Lanka in 2002?
Your answer should be compact. 3.00e+05. What is the difference between the Aid flow from UN agencies (US$) of Bulgaria in 2001 and the Aid flow from UN agencies (US$) of Croatia in 2002?
Provide a short and direct response. 5.30e+05. What is the difference between the Aid flow from UN agencies (US$) of Bulgaria in 2001 and the Aid flow from UN agencies (US$) of Mali in 2002?
Provide a succinct answer. -2.91e+06. What is the difference between the Aid flow from UN agencies (US$) in Bulgaria in 2001 and the Aid flow from UN agencies (US$) in Sri Lanka in 2002?
Offer a terse response. -1.01e+06. What is the difference between the Aid flow from UN agencies (US$) of Croatia in 2001 and the Aid flow from UN agencies (US$) of Mali in 2002?
Make the answer very short. -3.34e+06. What is the difference between the Aid flow from UN agencies (US$) of Croatia in 2001 and the Aid flow from UN agencies (US$) of Sri Lanka in 2002?
Your response must be concise. -1.44e+06. What is the difference between the Aid flow from UN agencies (US$) in Mali in 2001 and the Aid flow from UN agencies (US$) in Sri Lanka in 2002?
Make the answer very short. 9.70e+05. What is the average Aid flow from UN agencies (US$) in Bulgaria per year?
Give a very brief answer. 8.08e+05. What is the average Aid flow from UN agencies (US$) in Croatia per year?
Make the answer very short. 5.14e+05. What is the average Aid flow from UN agencies (US$) of Mali per year?
Your answer should be compact. 6.44e+06. What is the average Aid flow from UN agencies (US$) in Sri Lanka per year?
Give a very brief answer. 4.52e+06. In the year 1995, what is the difference between the Aid flow from UN agencies (US$) of Bulgaria and Aid flow from UN agencies (US$) of Mali?
Keep it short and to the point. -5.96e+06. In the year 1995, what is the difference between the Aid flow from UN agencies (US$) in Bulgaria and Aid flow from UN agencies (US$) in Sri Lanka?
Offer a very short reply. -4.17e+06. In the year 1995, what is the difference between the Aid flow from UN agencies (US$) in Croatia and Aid flow from UN agencies (US$) in Mali?
Provide a succinct answer. -6.31e+06. In the year 1995, what is the difference between the Aid flow from UN agencies (US$) of Croatia and Aid flow from UN agencies (US$) of Sri Lanka?
Your answer should be very brief. -4.52e+06. In the year 1995, what is the difference between the Aid flow from UN agencies (US$) of Mali and Aid flow from UN agencies (US$) of Sri Lanka?
Provide a short and direct response. 1.79e+06. In the year 1996, what is the difference between the Aid flow from UN agencies (US$) in Bulgaria and Aid flow from UN agencies (US$) in Croatia?
Keep it short and to the point. -6.10e+05. In the year 1996, what is the difference between the Aid flow from UN agencies (US$) of Bulgaria and Aid flow from UN agencies (US$) of Mali?
Your answer should be compact. -7.72e+06. In the year 1996, what is the difference between the Aid flow from UN agencies (US$) of Bulgaria and Aid flow from UN agencies (US$) of Sri Lanka?
Make the answer very short. -3.55e+06. In the year 1996, what is the difference between the Aid flow from UN agencies (US$) in Croatia and Aid flow from UN agencies (US$) in Mali?
Provide a succinct answer. -7.11e+06. In the year 1996, what is the difference between the Aid flow from UN agencies (US$) of Croatia and Aid flow from UN agencies (US$) of Sri Lanka?
Offer a very short reply. -2.94e+06. In the year 1996, what is the difference between the Aid flow from UN agencies (US$) in Mali and Aid flow from UN agencies (US$) in Sri Lanka?
Your answer should be compact. 4.17e+06. In the year 1997, what is the difference between the Aid flow from UN agencies (US$) in Bulgaria and Aid flow from UN agencies (US$) in Croatia?
Provide a short and direct response. 7.90e+05. In the year 1997, what is the difference between the Aid flow from UN agencies (US$) of Bulgaria and Aid flow from UN agencies (US$) of Mali?
Offer a terse response. -1.04e+07. In the year 1997, what is the difference between the Aid flow from UN agencies (US$) in Bulgaria and Aid flow from UN agencies (US$) in Sri Lanka?
Ensure brevity in your answer.  -5.68e+06. In the year 1997, what is the difference between the Aid flow from UN agencies (US$) of Croatia and Aid flow from UN agencies (US$) of Mali?
Make the answer very short. -1.12e+07. In the year 1997, what is the difference between the Aid flow from UN agencies (US$) of Croatia and Aid flow from UN agencies (US$) of Sri Lanka?
Make the answer very short. -6.47e+06. In the year 1997, what is the difference between the Aid flow from UN agencies (US$) of Mali and Aid flow from UN agencies (US$) of Sri Lanka?
Your response must be concise. 4.72e+06. In the year 1998, what is the difference between the Aid flow from UN agencies (US$) of Bulgaria and Aid flow from UN agencies (US$) of Mali?
Provide a succinct answer. -8.43e+06. In the year 1998, what is the difference between the Aid flow from UN agencies (US$) in Bulgaria and Aid flow from UN agencies (US$) in Sri Lanka?
Provide a succinct answer. -3.98e+06. In the year 1998, what is the difference between the Aid flow from UN agencies (US$) of Croatia and Aid flow from UN agencies (US$) of Mali?
Keep it short and to the point. -8.74e+06. In the year 1998, what is the difference between the Aid flow from UN agencies (US$) of Croatia and Aid flow from UN agencies (US$) of Sri Lanka?
Offer a very short reply. -4.29e+06. In the year 1998, what is the difference between the Aid flow from UN agencies (US$) in Mali and Aid flow from UN agencies (US$) in Sri Lanka?
Keep it short and to the point. 4.45e+06. In the year 1999, what is the difference between the Aid flow from UN agencies (US$) in Bulgaria and Aid flow from UN agencies (US$) in Croatia?
Your response must be concise. -2.20e+05. In the year 1999, what is the difference between the Aid flow from UN agencies (US$) in Bulgaria and Aid flow from UN agencies (US$) in Mali?
Your answer should be very brief. -6.56e+06. In the year 1999, what is the difference between the Aid flow from UN agencies (US$) in Bulgaria and Aid flow from UN agencies (US$) in Sri Lanka?
Ensure brevity in your answer.  -4.70e+06. In the year 1999, what is the difference between the Aid flow from UN agencies (US$) of Croatia and Aid flow from UN agencies (US$) of Mali?
Offer a very short reply. -6.34e+06. In the year 1999, what is the difference between the Aid flow from UN agencies (US$) of Croatia and Aid flow from UN agencies (US$) of Sri Lanka?
Give a very brief answer. -4.48e+06. In the year 1999, what is the difference between the Aid flow from UN agencies (US$) of Mali and Aid flow from UN agencies (US$) of Sri Lanka?
Provide a succinct answer. 1.86e+06. In the year 2000, what is the difference between the Aid flow from UN agencies (US$) of Bulgaria and Aid flow from UN agencies (US$) of Croatia?
Give a very brief answer. 7.20e+05. In the year 2000, what is the difference between the Aid flow from UN agencies (US$) in Bulgaria and Aid flow from UN agencies (US$) in Mali?
Your answer should be compact. -1.13e+06. In the year 2000, what is the difference between the Aid flow from UN agencies (US$) in Bulgaria and Aid flow from UN agencies (US$) in Sri Lanka?
Keep it short and to the point. -4.16e+06. In the year 2000, what is the difference between the Aid flow from UN agencies (US$) in Croatia and Aid flow from UN agencies (US$) in Mali?
Make the answer very short. -1.85e+06. In the year 2000, what is the difference between the Aid flow from UN agencies (US$) in Croatia and Aid flow from UN agencies (US$) in Sri Lanka?
Provide a short and direct response. -4.88e+06. In the year 2000, what is the difference between the Aid flow from UN agencies (US$) of Mali and Aid flow from UN agencies (US$) of Sri Lanka?
Keep it short and to the point. -3.03e+06. In the year 2001, what is the difference between the Aid flow from UN agencies (US$) in Bulgaria and Aid flow from UN agencies (US$) in Croatia?
Keep it short and to the point. 4.30e+05. In the year 2001, what is the difference between the Aid flow from UN agencies (US$) in Bulgaria and Aid flow from UN agencies (US$) in Mali?
Your answer should be compact. -1.98e+06. In the year 2001, what is the difference between the Aid flow from UN agencies (US$) of Bulgaria and Aid flow from UN agencies (US$) of Sri Lanka?
Keep it short and to the point. -2.53e+06. In the year 2001, what is the difference between the Aid flow from UN agencies (US$) of Croatia and Aid flow from UN agencies (US$) of Mali?
Give a very brief answer. -2.41e+06. In the year 2001, what is the difference between the Aid flow from UN agencies (US$) in Croatia and Aid flow from UN agencies (US$) in Sri Lanka?
Your answer should be very brief. -2.96e+06. In the year 2001, what is the difference between the Aid flow from UN agencies (US$) of Mali and Aid flow from UN agencies (US$) of Sri Lanka?
Offer a very short reply. -5.50e+05. In the year 2002, what is the difference between the Aid flow from UN agencies (US$) in Bulgaria and Aid flow from UN agencies (US$) in Croatia?
Your answer should be very brief. 5.80e+05. In the year 2002, what is the difference between the Aid flow from UN agencies (US$) of Bulgaria and Aid flow from UN agencies (US$) of Mali?
Keep it short and to the point. -2.86e+06. In the year 2002, what is the difference between the Aid flow from UN agencies (US$) of Bulgaria and Aid flow from UN agencies (US$) of Sri Lanka?
Offer a terse response. -9.60e+05. In the year 2002, what is the difference between the Aid flow from UN agencies (US$) of Croatia and Aid flow from UN agencies (US$) of Mali?
Offer a terse response. -3.44e+06. In the year 2002, what is the difference between the Aid flow from UN agencies (US$) of Croatia and Aid flow from UN agencies (US$) of Sri Lanka?
Make the answer very short. -1.54e+06. In the year 2002, what is the difference between the Aid flow from UN agencies (US$) in Mali and Aid flow from UN agencies (US$) in Sri Lanka?
Your response must be concise. 1.90e+06. What is the ratio of the Aid flow from UN agencies (US$) in Croatia in 1995 to that in 1996?
Offer a terse response. 0.04. What is the ratio of the Aid flow from UN agencies (US$) in Mali in 1995 to that in 1996?
Ensure brevity in your answer.  0.76. What is the ratio of the Aid flow from UN agencies (US$) in Sri Lanka in 1995 to that in 1996?
Make the answer very short. 1.1. What is the ratio of the Aid flow from UN agencies (US$) of Bulgaria in 1995 to that in 1997?
Your answer should be very brief. 0.43. What is the ratio of the Aid flow from UN agencies (US$) in Croatia in 1995 to that in 1997?
Ensure brevity in your answer.  0.38. What is the ratio of the Aid flow from UN agencies (US$) in Mali in 1995 to that in 1997?
Provide a short and direct response. 0.56. What is the ratio of the Aid flow from UN agencies (US$) of Sri Lanka in 1995 to that in 1997?
Offer a very short reply. 0.69. What is the ratio of the Aid flow from UN agencies (US$) in Bulgaria in 1995 to that in 1998?
Keep it short and to the point. 0.28. What is the ratio of the Aid flow from UN agencies (US$) in Croatia in 1995 to that in 1998?
Ensure brevity in your answer.  0.05. What is the ratio of the Aid flow from UN agencies (US$) in Mali in 1995 to that in 1998?
Provide a succinct answer. 0.65. What is the ratio of the Aid flow from UN agencies (US$) in Sri Lanka in 1995 to that in 1998?
Ensure brevity in your answer.  0.85. What is the ratio of the Aid flow from UN agencies (US$) in Bulgaria in 1995 to that in 1999?
Your response must be concise. 0.42. What is the ratio of the Aid flow from UN agencies (US$) in Croatia in 1995 to that in 1999?
Provide a short and direct response. 0.04. What is the ratio of the Aid flow from UN agencies (US$) in Mali in 1995 to that in 1999?
Keep it short and to the point. 0.85. What is the ratio of the Aid flow from UN agencies (US$) in Sri Lanka in 1995 to that in 1999?
Offer a terse response. 0.81. What is the ratio of the Aid flow from UN agencies (US$) in Bulgaria in 1995 to that in 2000?
Offer a terse response. 0.48. What is the ratio of the Aid flow from UN agencies (US$) of Croatia in 1995 to that in 2000?
Your answer should be compact. 0.45. What is the ratio of the Aid flow from UN agencies (US$) of Mali in 1995 to that in 2000?
Your answer should be very brief. 3.24. What is the ratio of the Aid flow from UN agencies (US$) of Sri Lanka in 1995 to that in 2000?
Ensure brevity in your answer.  0.92. What is the ratio of the Aid flow from UN agencies (US$) in Bulgaria in 1995 to that in 2001?
Make the answer very short. 0.62. What is the ratio of the Aid flow from UN agencies (US$) in Croatia in 1995 to that in 2001?
Keep it short and to the point. 0.23. What is the ratio of the Aid flow from UN agencies (US$) in Mali in 1995 to that in 2001?
Your answer should be compact. 2.42. What is the ratio of the Aid flow from UN agencies (US$) in Sri Lanka in 1995 to that in 2001?
Your answer should be very brief. 1.44. What is the ratio of the Aid flow from UN agencies (US$) of Croatia in 1995 to that in 2002?
Keep it short and to the point. 0.42. What is the ratio of the Aid flow from UN agencies (US$) in Mali in 1995 to that in 2002?
Give a very brief answer. 1.79. What is the ratio of the Aid flow from UN agencies (US$) in Sri Lanka in 1995 to that in 2002?
Make the answer very short. 2.75. What is the ratio of the Aid flow from UN agencies (US$) in Bulgaria in 1996 to that in 1997?
Your answer should be very brief. 0.65. What is the ratio of the Aid flow from UN agencies (US$) in Croatia in 1996 to that in 1997?
Provide a succinct answer. 9.31. What is the ratio of the Aid flow from UN agencies (US$) of Mali in 1996 to that in 1997?
Make the answer very short. 0.73. What is the ratio of the Aid flow from UN agencies (US$) in Sri Lanka in 1996 to that in 1997?
Your answer should be very brief. 0.63. What is the ratio of the Aid flow from UN agencies (US$) of Bulgaria in 1996 to that in 1998?
Offer a very short reply. 0.43. What is the ratio of the Aid flow from UN agencies (US$) in Croatia in 1996 to that in 1998?
Offer a terse response. 1.1. What is the ratio of the Aid flow from UN agencies (US$) in Mali in 1996 to that in 1998?
Ensure brevity in your answer.  0.85. What is the ratio of the Aid flow from UN agencies (US$) in Sri Lanka in 1996 to that in 1998?
Keep it short and to the point. 0.77. What is the ratio of the Aid flow from UN agencies (US$) in Bulgaria in 1996 to that in 1999?
Offer a terse response. 0.63. What is the ratio of the Aid flow from UN agencies (US$) in Croatia in 1996 to that in 1999?
Provide a succinct answer. 1.03. What is the ratio of the Aid flow from UN agencies (US$) of Mali in 1996 to that in 1999?
Offer a very short reply. 1.11. What is the ratio of the Aid flow from UN agencies (US$) of Sri Lanka in 1996 to that in 1999?
Your answer should be very brief. 0.73. What is the ratio of the Aid flow from UN agencies (US$) of Bulgaria in 1996 to that in 2000?
Your answer should be very brief. 0.72. What is the ratio of the Aid flow from UN agencies (US$) in Croatia in 1996 to that in 2000?
Ensure brevity in your answer.  11. What is the ratio of the Aid flow from UN agencies (US$) of Mali in 1996 to that in 2000?
Your answer should be compact. 4.24. What is the ratio of the Aid flow from UN agencies (US$) in Sri Lanka in 1996 to that in 2000?
Make the answer very short. 0.83. What is the ratio of the Aid flow from UN agencies (US$) in Bulgaria in 1996 to that in 2001?
Your answer should be compact. 0.92. What is the ratio of the Aid flow from UN agencies (US$) of Croatia in 1996 to that in 2001?
Provide a succinct answer. 5.5. What is the ratio of the Aid flow from UN agencies (US$) of Mali in 1996 to that in 2001?
Provide a succinct answer. 3.16. What is the ratio of the Aid flow from UN agencies (US$) in Sri Lanka in 1996 to that in 2001?
Ensure brevity in your answer.  1.3. What is the ratio of the Aid flow from UN agencies (US$) of Bulgaria in 1996 to that in 2002?
Ensure brevity in your answer.  0.86. What is the ratio of the Aid flow from UN agencies (US$) in Croatia in 1996 to that in 2002?
Your answer should be very brief. 10.08. What is the ratio of the Aid flow from UN agencies (US$) of Mali in 1996 to that in 2002?
Your answer should be very brief. 2.34. What is the ratio of the Aid flow from UN agencies (US$) of Bulgaria in 1997 to that in 1998?
Provide a succinct answer. 0.65. What is the ratio of the Aid flow from UN agencies (US$) of Croatia in 1997 to that in 1998?
Make the answer very short. 0.12. What is the ratio of the Aid flow from UN agencies (US$) in Mali in 1997 to that in 1998?
Ensure brevity in your answer.  1.15. What is the ratio of the Aid flow from UN agencies (US$) in Sri Lanka in 1997 to that in 1998?
Keep it short and to the point. 1.22. What is the ratio of the Aid flow from UN agencies (US$) of Bulgaria in 1997 to that in 1999?
Keep it short and to the point. 0.97. What is the ratio of the Aid flow from UN agencies (US$) in Mali in 1997 to that in 1999?
Keep it short and to the point. 1.51. What is the ratio of the Aid flow from UN agencies (US$) of Sri Lanka in 1997 to that in 1999?
Your answer should be compact. 1.17. What is the ratio of the Aid flow from UN agencies (US$) in Bulgaria in 1997 to that in 2000?
Ensure brevity in your answer.  1.11. What is the ratio of the Aid flow from UN agencies (US$) in Croatia in 1997 to that in 2000?
Your answer should be compact. 1.18. What is the ratio of the Aid flow from UN agencies (US$) of Mali in 1997 to that in 2000?
Provide a succinct answer. 5.78. What is the ratio of the Aid flow from UN agencies (US$) of Sri Lanka in 1997 to that in 2000?
Offer a very short reply. 1.32. What is the ratio of the Aid flow from UN agencies (US$) of Bulgaria in 1997 to that in 2001?
Give a very brief answer. 1.42. What is the ratio of the Aid flow from UN agencies (US$) of Croatia in 1997 to that in 2001?
Provide a succinct answer. 0.59. What is the ratio of the Aid flow from UN agencies (US$) in Mali in 1997 to that in 2001?
Give a very brief answer. 4.3. What is the ratio of the Aid flow from UN agencies (US$) of Sri Lanka in 1997 to that in 2001?
Your answer should be compact. 2.08. What is the ratio of the Aid flow from UN agencies (US$) of Bulgaria in 1997 to that in 2002?
Offer a very short reply. 1.31. What is the ratio of the Aid flow from UN agencies (US$) in Mali in 1997 to that in 2002?
Your answer should be compact. 3.18. What is the ratio of the Aid flow from UN agencies (US$) in Sri Lanka in 1997 to that in 2002?
Make the answer very short. 3.98. What is the ratio of the Aid flow from UN agencies (US$) in Bulgaria in 1998 to that in 1999?
Offer a very short reply. 1.48. What is the ratio of the Aid flow from UN agencies (US$) of Croatia in 1998 to that in 1999?
Your answer should be very brief. 0.94. What is the ratio of the Aid flow from UN agencies (US$) of Mali in 1998 to that in 1999?
Give a very brief answer. 1.31. What is the ratio of the Aid flow from UN agencies (US$) in Sri Lanka in 1998 to that in 1999?
Your response must be concise. 0.95. What is the ratio of the Aid flow from UN agencies (US$) in Bulgaria in 1998 to that in 2000?
Offer a terse response. 1.7. What is the ratio of the Aid flow from UN agencies (US$) in Mali in 1998 to that in 2000?
Give a very brief answer. 5.02. What is the ratio of the Aid flow from UN agencies (US$) of Sri Lanka in 1998 to that in 2000?
Keep it short and to the point. 1.08. What is the ratio of the Aid flow from UN agencies (US$) of Bulgaria in 1998 to that in 2001?
Offer a very short reply. 2.17. What is the ratio of the Aid flow from UN agencies (US$) of Mali in 1998 to that in 2001?
Keep it short and to the point. 3.74. What is the ratio of the Aid flow from UN agencies (US$) in Sri Lanka in 1998 to that in 2001?
Offer a very short reply. 1.7. What is the ratio of the Aid flow from UN agencies (US$) of Bulgaria in 1998 to that in 2002?
Your answer should be very brief. 2.01. What is the ratio of the Aid flow from UN agencies (US$) in Croatia in 1998 to that in 2002?
Offer a very short reply. 9.17. What is the ratio of the Aid flow from UN agencies (US$) of Mali in 1998 to that in 2002?
Your answer should be compact. 2.76. What is the ratio of the Aid flow from UN agencies (US$) of Sri Lanka in 1998 to that in 2002?
Keep it short and to the point. 3.25. What is the ratio of the Aid flow from UN agencies (US$) of Bulgaria in 1999 to that in 2000?
Ensure brevity in your answer.  1.14. What is the ratio of the Aid flow from UN agencies (US$) of Croatia in 1999 to that in 2000?
Your answer should be very brief. 10.64. What is the ratio of the Aid flow from UN agencies (US$) in Mali in 1999 to that in 2000?
Offer a very short reply. 3.83. What is the ratio of the Aid flow from UN agencies (US$) of Sri Lanka in 1999 to that in 2000?
Make the answer very short. 1.13. What is the ratio of the Aid flow from UN agencies (US$) of Bulgaria in 1999 to that in 2001?
Your response must be concise. 1.46. What is the ratio of the Aid flow from UN agencies (US$) in Croatia in 1999 to that in 2001?
Provide a short and direct response. 5.32. What is the ratio of the Aid flow from UN agencies (US$) in Mali in 1999 to that in 2001?
Offer a terse response. 2.86. What is the ratio of the Aid flow from UN agencies (US$) of Sri Lanka in 1999 to that in 2001?
Offer a terse response. 1.78. What is the ratio of the Aid flow from UN agencies (US$) of Bulgaria in 1999 to that in 2002?
Ensure brevity in your answer.  1.36. What is the ratio of the Aid flow from UN agencies (US$) in Croatia in 1999 to that in 2002?
Make the answer very short. 9.75. What is the ratio of the Aid flow from UN agencies (US$) of Mali in 1999 to that in 2002?
Offer a terse response. 2.11. What is the ratio of the Aid flow from UN agencies (US$) in Sri Lanka in 1999 to that in 2002?
Offer a very short reply. 3.4. What is the ratio of the Aid flow from UN agencies (US$) in Bulgaria in 2000 to that in 2001?
Provide a short and direct response. 1.28. What is the ratio of the Aid flow from UN agencies (US$) in Croatia in 2000 to that in 2001?
Your answer should be compact. 0.5. What is the ratio of the Aid flow from UN agencies (US$) of Mali in 2000 to that in 2001?
Provide a succinct answer. 0.75. What is the ratio of the Aid flow from UN agencies (US$) of Sri Lanka in 2000 to that in 2001?
Offer a very short reply. 1.57. What is the ratio of the Aid flow from UN agencies (US$) of Bulgaria in 2000 to that in 2002?
Make the answer very short. 1.19. What is the ratio of the Aid flow from UN agencies (US$) of Croatia in 2000 to that in 2002?
Ensure brevity in your answer.  0.92. What is the ratio of the Aid flow from UN agencies (US$) of Mali in 2000 to that in 2002?
Your answer should be very brief. 0.55. What is the ratio of the Aid flow from UN agencies (US$) of Sri Lanka in 2000 to that in 2002?
Your answer should be compact. 3.01. What is the ratio of the Aid flow from UN agencies (US$) in Bulgaria in 2001 to that in 2002?
Your answer should be compact. 0.93. What is the ratio of the Aid flow from UN agencies (US$) of Croatia in 2001 to that in 2002?
Your response must be concise. 1.83. What is the ratio of the Aid flow from UN agencies (US$) in Mali in 2001 to that in 2002?
Provide a succinct answer. 0.74. What is the ratio of the Aid flow from UN agencies (US$) of Sri Lanka in 2001 to that in 2002?
Make the answer very short. 1.92. What is the difference between the highest and the second highest Aid flow from UN agencies (US$) of Mali?
Make the answer very short. 1.48e+06. What is the difference between the highest and the second highest Aid flow from UN agencies (US$) in Sri Lanka?
Offer a terse response. 9.50e+05. What is the difference between the highest and the lowest Aid flow from UN agencies (US$) of Bulgaria?
Make the answer very short. 1.01e+06. What is the difference between the highest and the lowest Aid flow from UN agencies (US$) of Croatia?
Ensure brevity in your answer.  1.16e+06. What is the difference between the highest and the lowest Aid flow from UN agencies (US$) in Mali?
Offer a terse response. 9.36e+06. What is the difference between the highest and the lowest Aid flow from UN agencies (US$) of Sri Lanka?
Your response must be concise. 4.94e+06. 